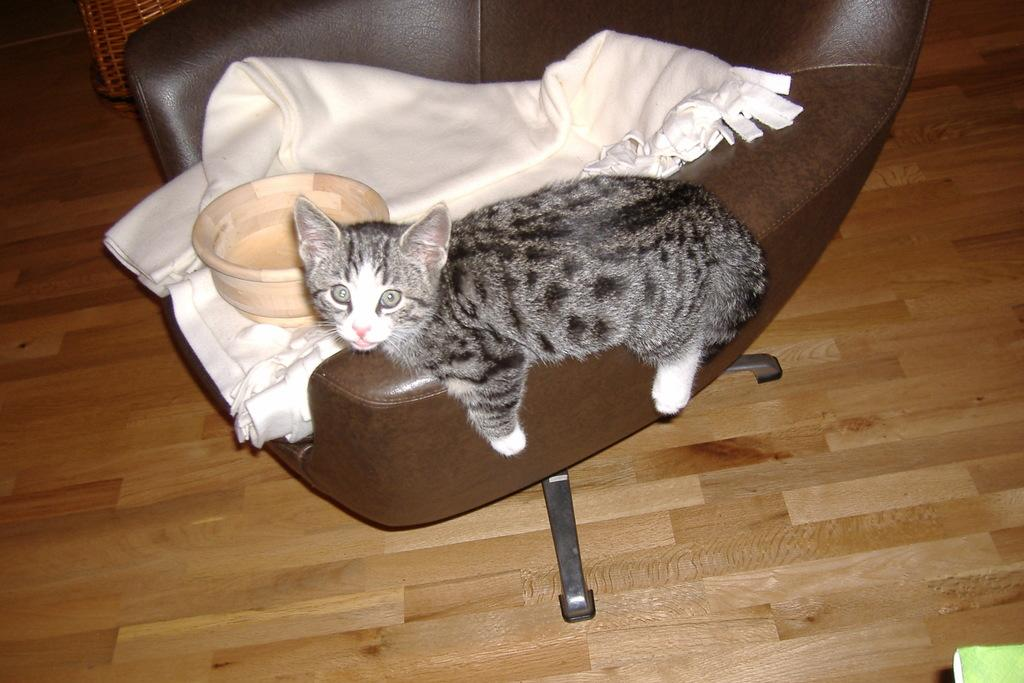What type of animal can be seen in the image? There is a cat in the image. What object is present in the image that could be used for holding or serving food or drink? There is a bowl in the image. What piece of furniture is covered with a blanket in the image? There is a blanket on a chair in the image. What type of flooring is visible in the image? The chair is placed on the wooden floor in the image. What is located at the top left of the image? There is a basket at the top left of the image. Can you see a seashore in the image? No, there is no seashore present in the image. Is the cat wearing a crown in the image? No, the cat is not wearing a crown in the image. 